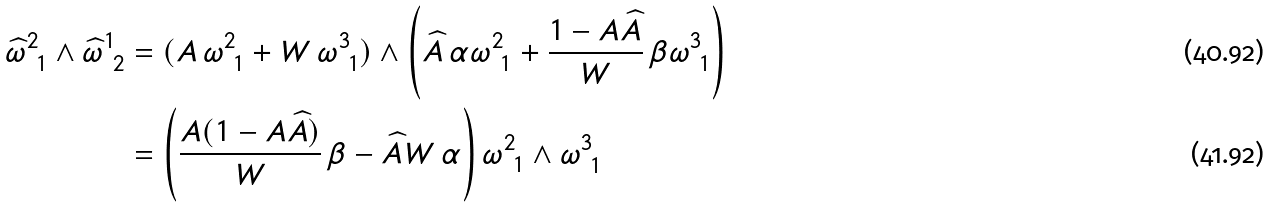Convert formula to latex. <formula><loc_0><loc_0><loc_500><loc_500>\widehat { \omega } ^ { 2 } _ { \ 1 } \wedge \widehat { \omega } ^ { 1 } _ { \ 2 } & = ( A \, \omega ^ { 2 } _ { \ 1 } + W \, \omega ^ { 3 } _ { \ 1 } ) \wedge \left ( \widehat { A } \, \alpha \omega ^ { 2 } _ { \ 1 } + \frac { 1 - A \widehat { A } } { W } \, \beta \omega ^ { 3 } _ { \ 1 } \right ) \\ & = \left ( \frac { A ( 1 - A \widehat { A } ) } { W } \, \beta - \widehat { A } W \, \alpha \right ) \omega ^ { 2 } _ { \ 1 } \wedge \omega ^ { 3 } _ { \ 1 }</formula> 